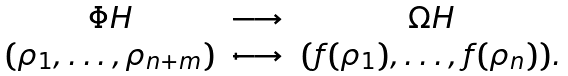<formula> <loc_0><loc_0><loc_500><loc_500>\begin{array} { c c c } \Phi H & \longrightarrow & \Omega H \\ ( \rho _ { 1 } , \dots , \rho _ { n + m } ) & \longmapsto & ( f ( \rho _ { 1 } ) , \dots , f ( \rho _ { n } ) ) . \end{array}</formula> 